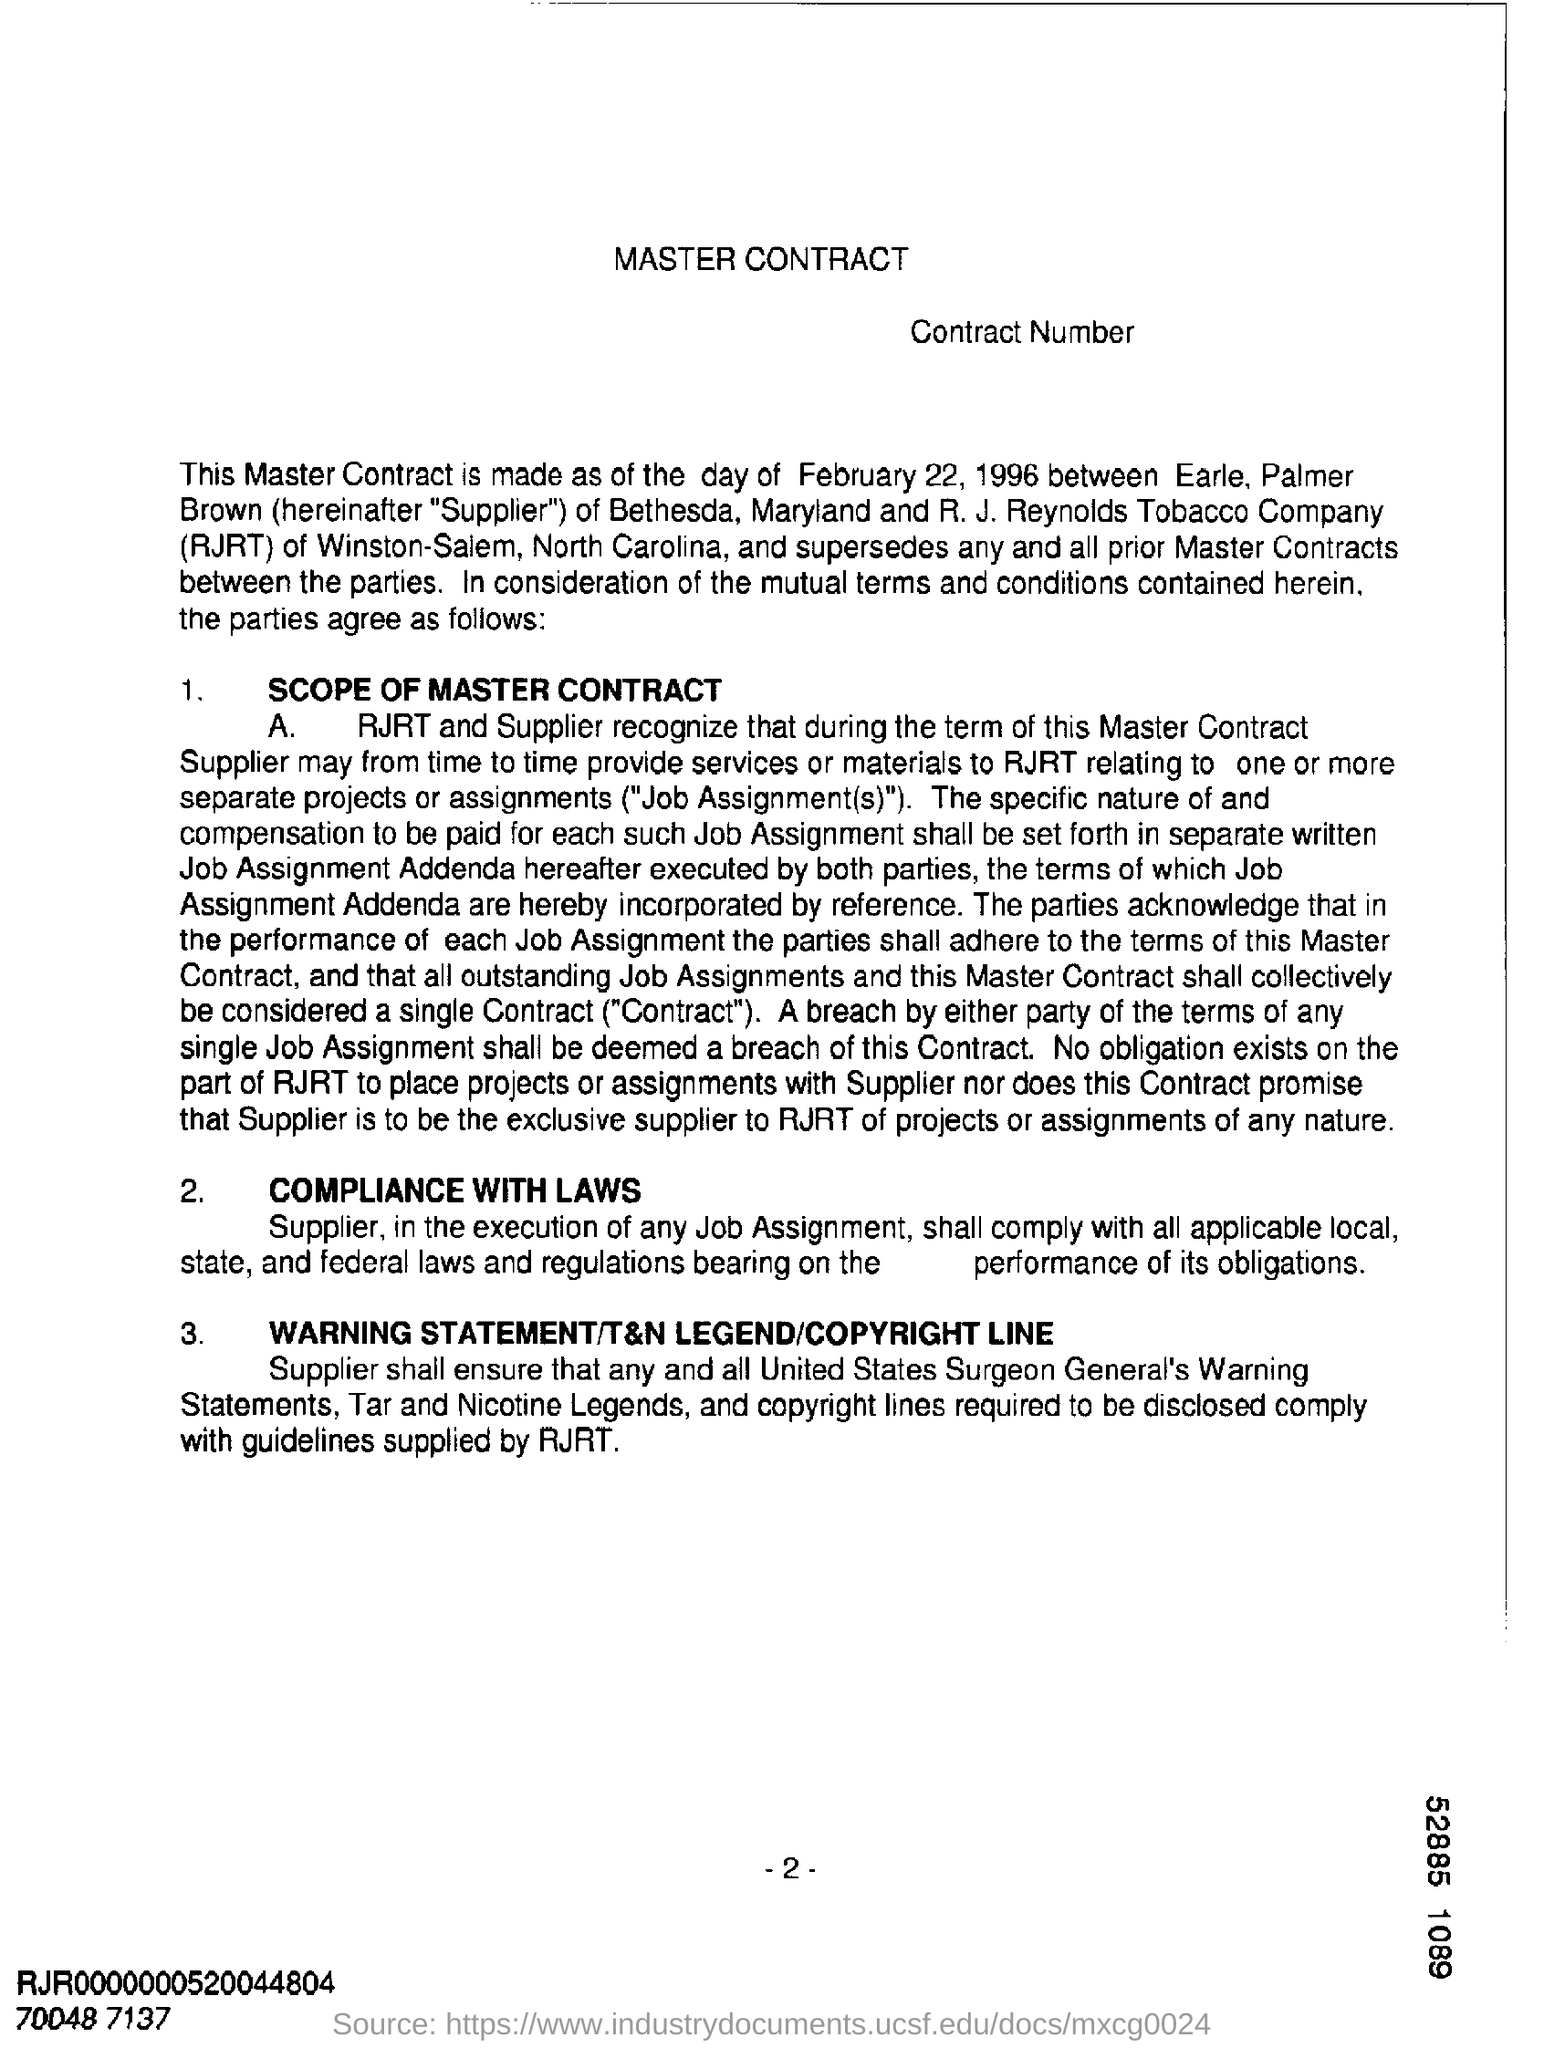When was this agreement made?
Give a very brief answer. February 22, 1996. What is the heading of the first point?
Make the answer very short. SCOPE OF MASTER CONTRACT. Which company's name is mentioned?
Your answer should be very brief. R. J. Reynolds  Tobacco Company. 